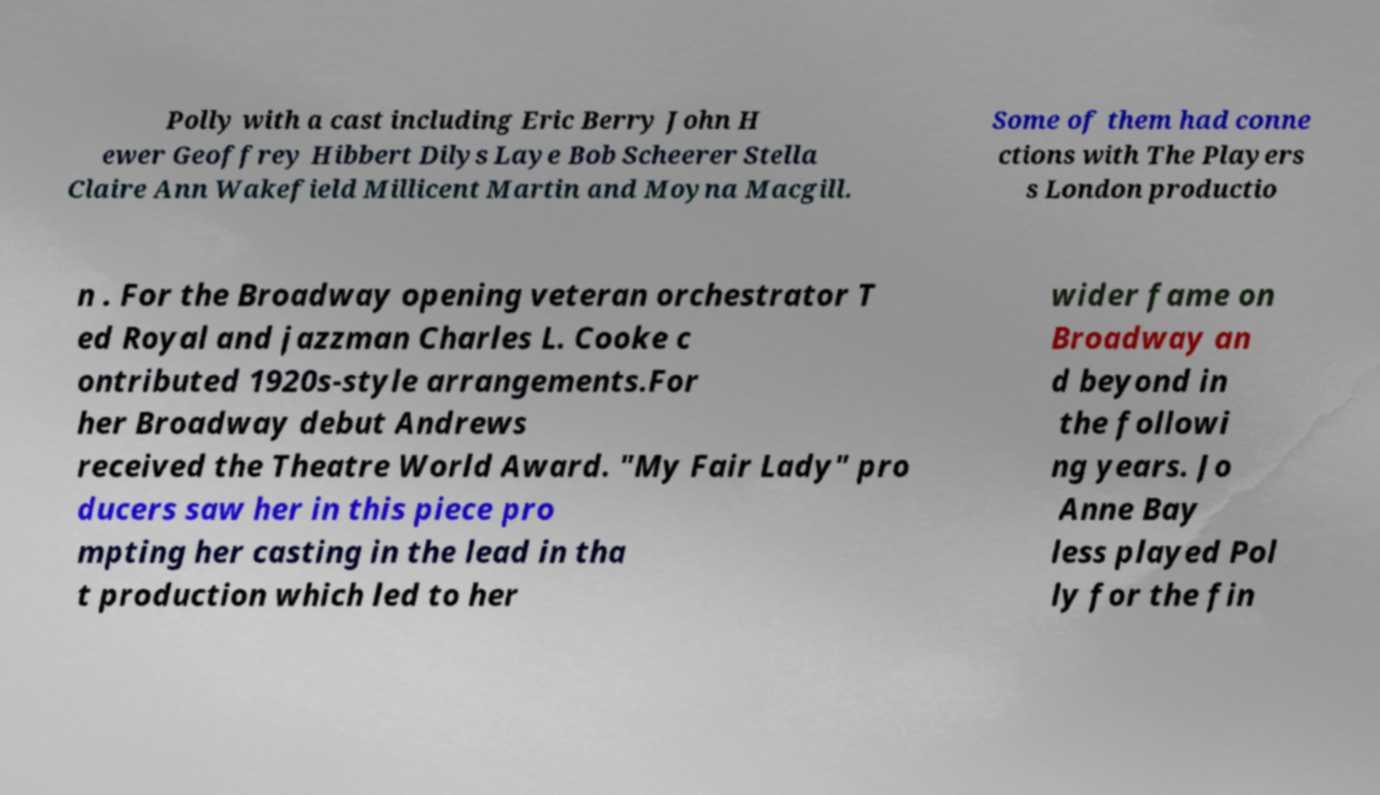Please identify and transcribe the text found in this image. Polly with a cast including Eric Berry John H ewer Geoffrey Hibbert Dilys Laye Bob Scheerer Stella Claire Ann Wakefield Millicent Martin and Moyna Macgill. Some of them had conne ctions with The Players s London productio n . For the Broadway opening veteran orchestrator T ed Royal and jazzman Charles L. Cooke c ontributed 1920s-style arrangements.For her Broadway debut Andrews received the Theatre World Award. "My Fair Lady" pro ducers saw her in this piece pro mpting her casting in the lead in tha t production which led to her wider fame on Broadway an d beyond in the followi ng years. Jo Anne Bay less played Pol ly for the fin 